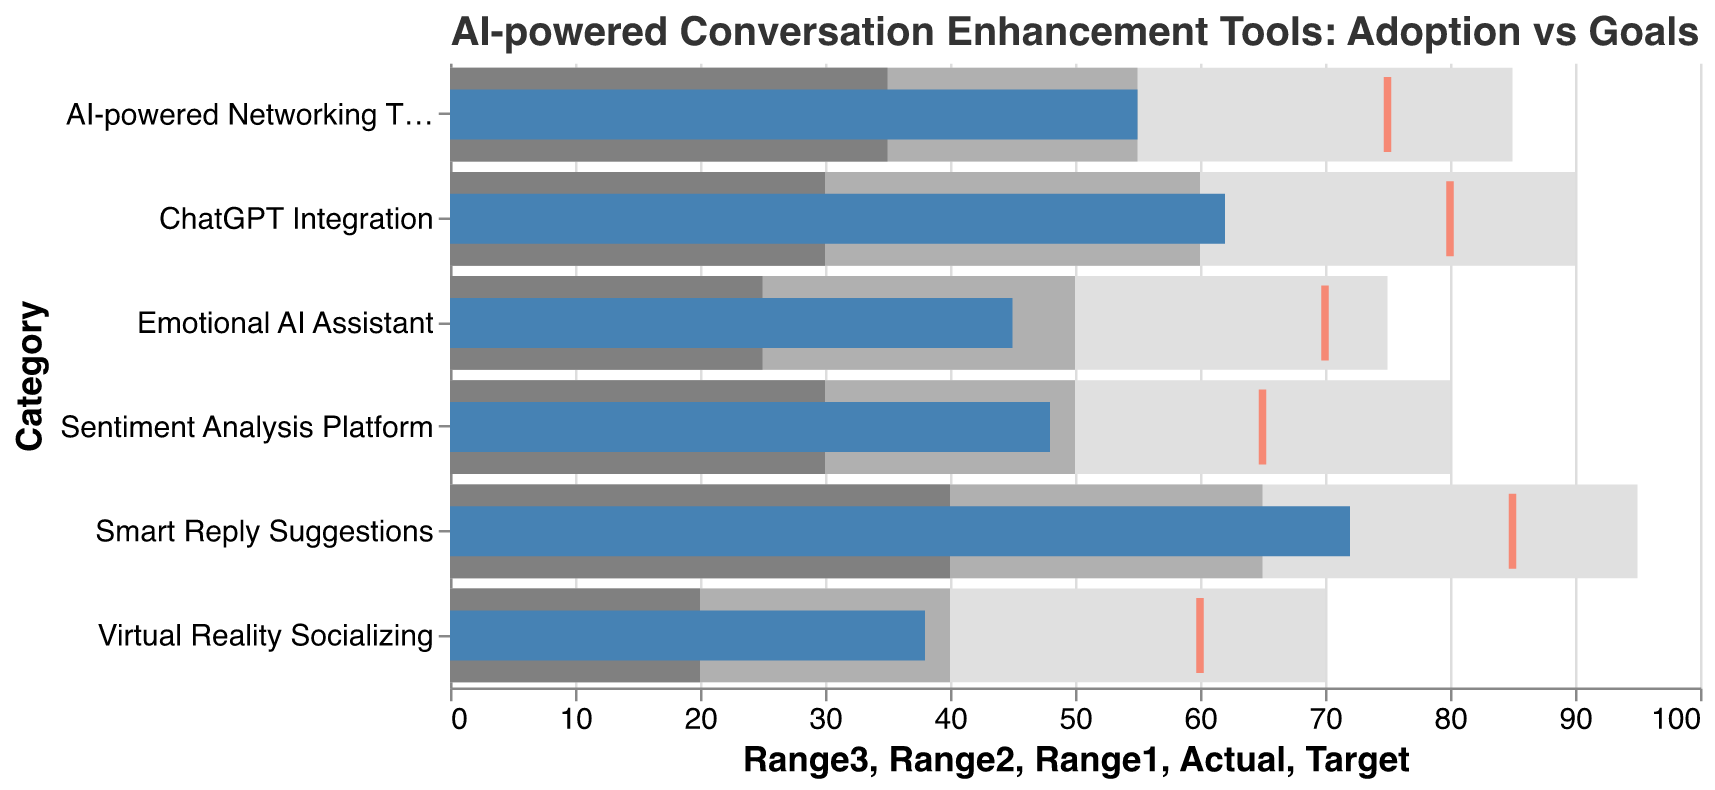What is the actual adoption rate of the Sentiment Analysis Platform? The actual adoption rate is represented by the blue bar corresponding to the "Sentiment Analysis Platform" category.
Answer: 48 Which tool has the highest target adoption rate? The tool with the highest target adoption rate is indicated by the tallest red tick mark.
Answer: Smart Reply Suggestions By how much did the ChatGPT Integration fall short of its target adoption rate? Subtract the actual adoption rate of ChatGPT Integration (62) from its target rate (80).
Answer: 18 What is the average of the actual adoption rates of all tools? Calculate the sum of the actual adoption rates (62 + 45 + 38 + 55 + 72 + 48) and divide by the number of tools (6). Sum is 320, and 320/6 = 53.33.
Answer: 53.33 How many tools have an actual adoption rate higher than 50? Check the actual adoption rates listed and count the number of rates greater than 50. ChatGPT Integration (62), AI-powered Networking Tools (55), and Smart Reply Suggestions (72).
Answer: 3 Which tool has the smallest difference between its actual and target adoption rates? Calculate the differences for each tool by subtracting the actual rate from the target rate: ChatGPT Integration (18), Emotional AI Assistant (25), Virtual Reality Socializing (22), AI-powered Networking Tools (20), Smart Reply Suggestions (13), Sentiment Analysis Platform (17).
Answer: Smart Reply Suggestions What is the range of adoption rates for the Emotional AI Assistant tool? The range is calculated by finding the difference between the highest range value (75) and the lowest range value (25).
Answer: 50 Is the actual adoption rate of any tool higher than its highest range? Compare the actual adoption rates with the Range3 values of each tool. None of the actual rates exceed their respective highest range values.
Answer: No Which tool falls into the lowest range category, and what is that range? Identify the tool where the actual adoption rate falls within the lowest range specified. Virtual Reality Socializing has an actual rate of 38, which falls in the range of 20-40.
Answer: Virtual Reality Socializing, 20-40 Which tool exceeds its Range2 but is below its target adoption rate? Compare actual adoption rates to Range2 and Target. ChatGPT Integration (62) falls between its Range2 (60) and Target (80).
Answer: ChatGPT Integration 